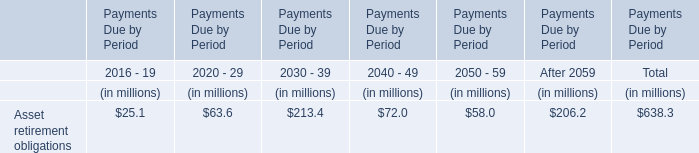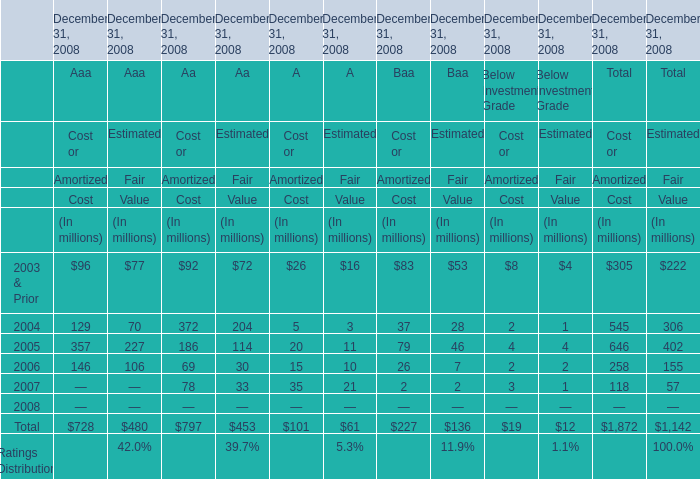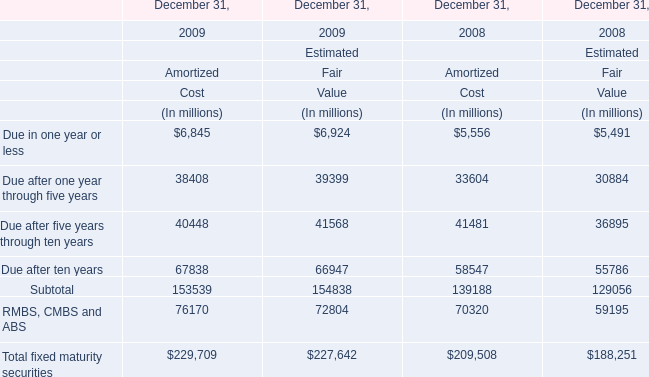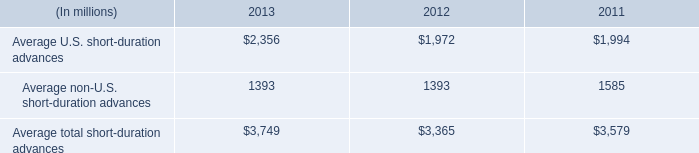what is the growth rate of the average total short-duration advances from 2011 to 2012? 
Computations: ((3365 - 3579) / 3579)
Answer: -0.05979. 